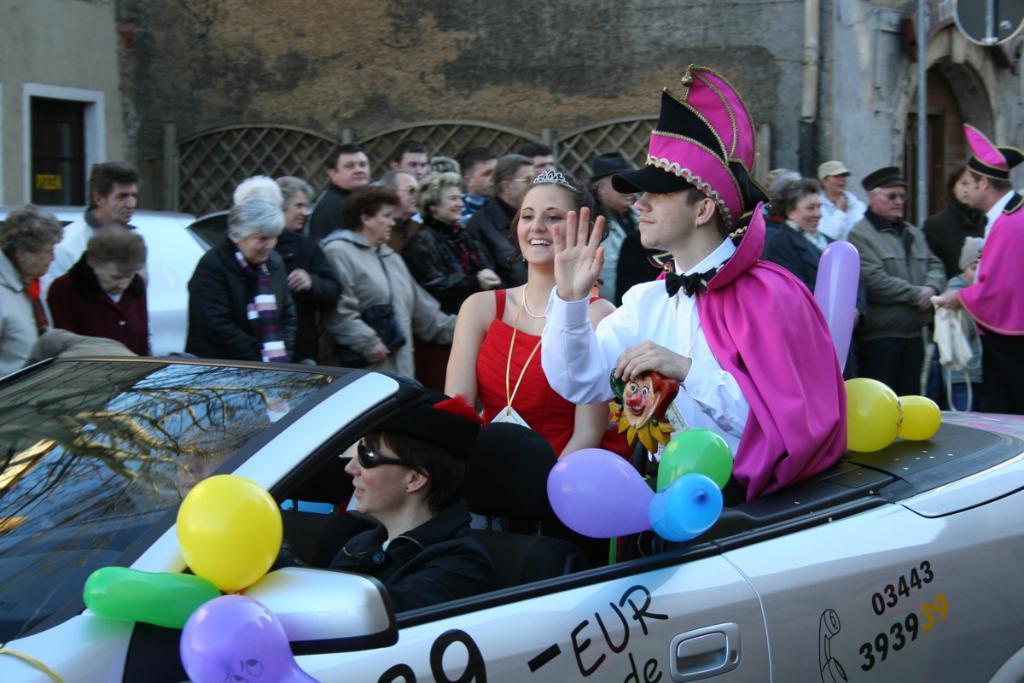Describe this image in one or two sentences. In this image there are group of persons standing, there is a wall, there is a window, there is a pole, there is an object truncated at the top of the image, there is a person truncated towards the right of the image, there is a car truncated, there are balloons, there are persons in the car, there are persons holding objects, there is text on the text, numbers on the car, there is a person truncated towards the left of the image. 